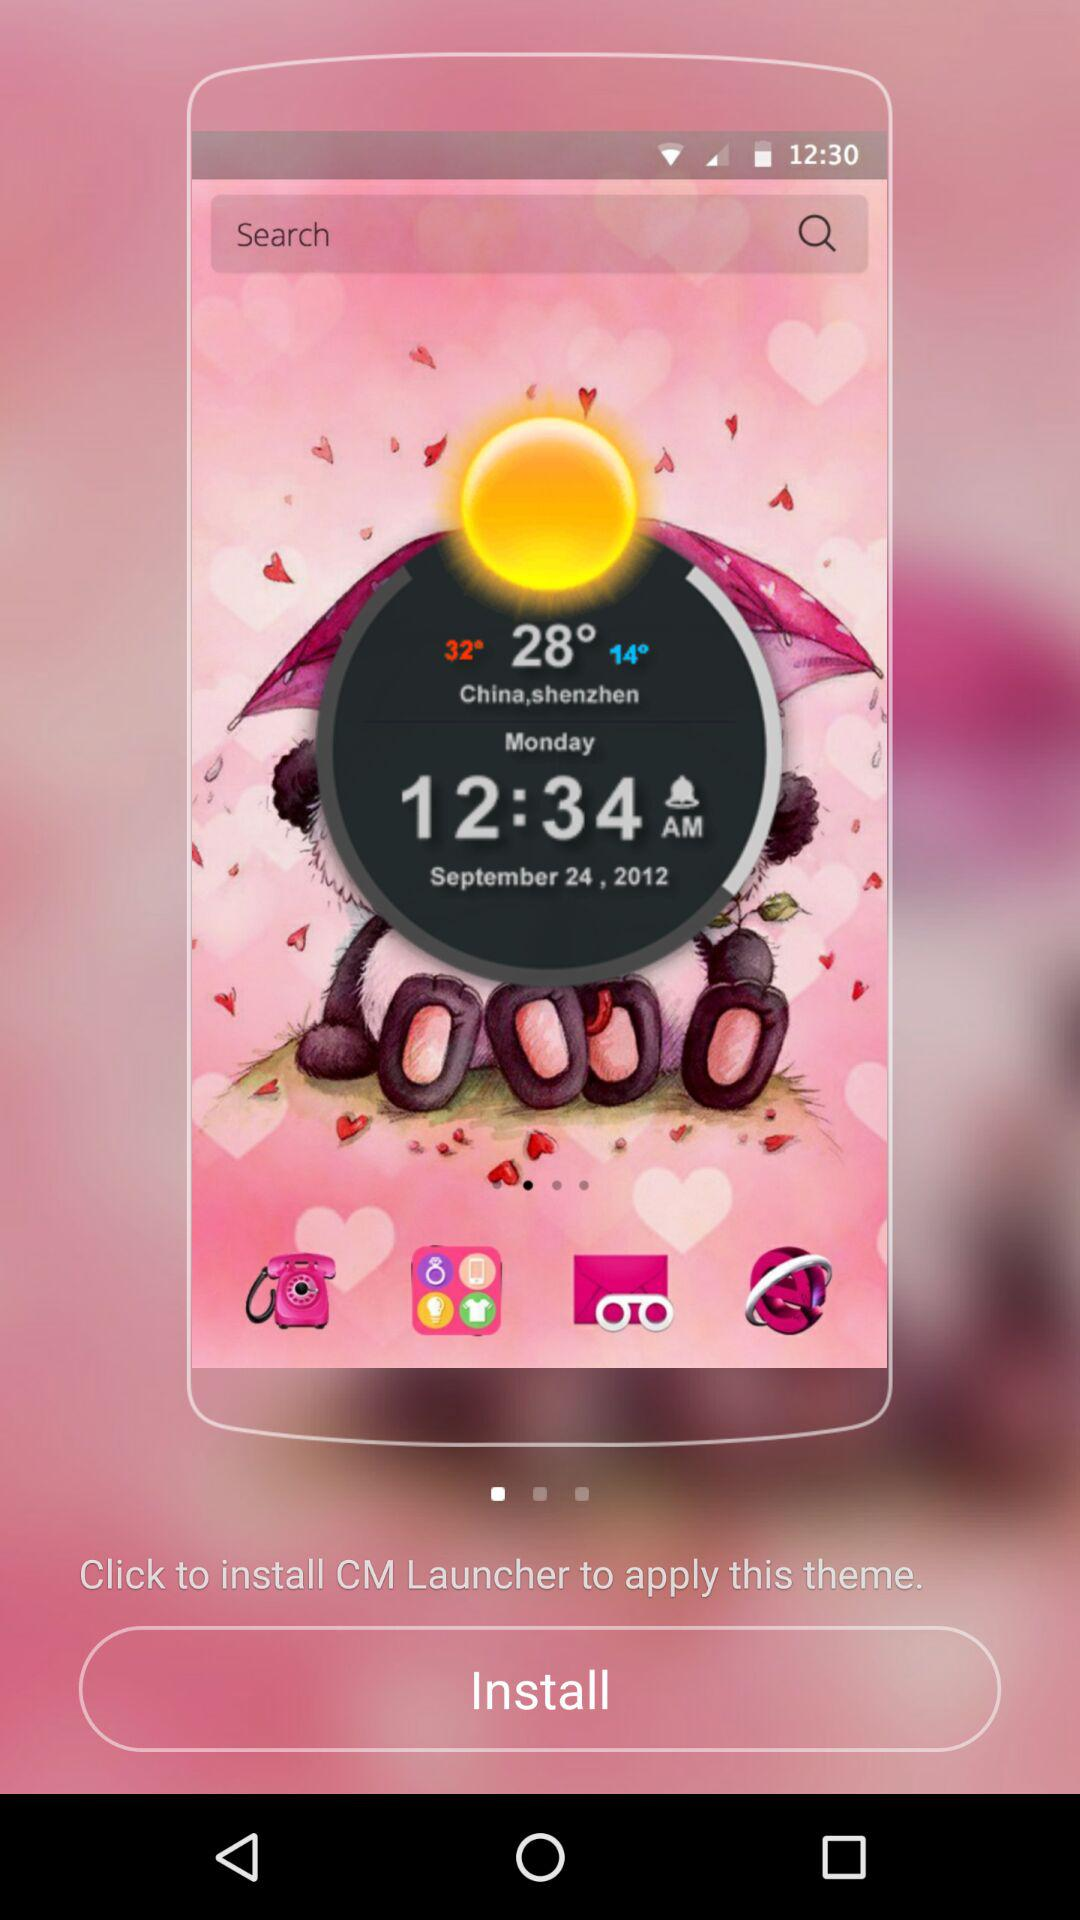What is the application name? The application name is "CM Launcher". 